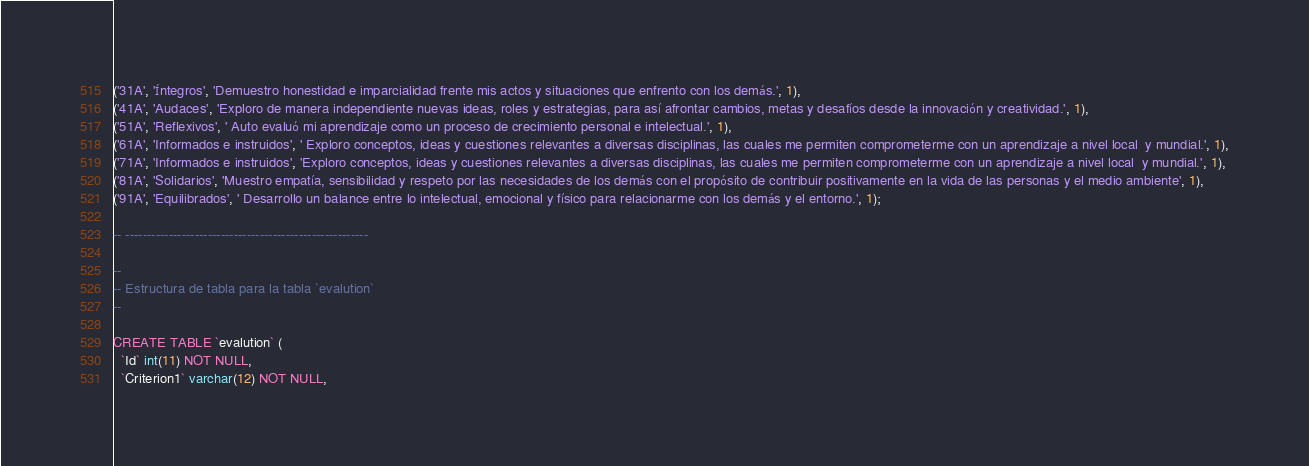<code> <loc_0><loc_0><loc_500><loc_500><_SQL_>('31A', 'Íntegros', 'Demuestro honestidad e imparcialidad frente mis actos y situaciones que enfrento con los demás.', 1),
('41A', 'Audaces', 'Exploro de manera independiente nuevas ideas, roles y estrategias, para así afrontar cambios, metas y desafíos desde la innovación y creatividad.', 1),
('51A', 'Reflexivos', ' Auto evaluó mi aprendizaje como un proceso de crecimiento personal e intelectual.', 1),
('61A', 'Informados e instruidos', ' Exploro conceptos, ideas y cuestiones relevantes a diversas disciplinas, las cuales me permiten comprometerme con un aprendizaje a nivel local  y mundial.', 1),
('71A', 'Informados e instruidos', 'Exploro conceptos, ideas y cuestiones relevantes a diversas disciplinas, las cuales me permiten comprometerme con un aprendizaje a nivel local  y mundial.', 1),
('81A', 'Solidarios', 'Muestro empatía, sensibilidad y respeto por las necesidades de los demás con el propósito de contribuir positivamente en la vida de las personas y el medio ambiente', 1),
('91A', 'Equilibrados', ' Desarrollo un balance entre lo intelectual, emocional y físico para relacionarme con los demás y el entorno.', 1);

-- --------------------------------------------------------

--
-- Estructura de tabla para la tabla `evalution`
--

CREATE TABLE `evalution` (
  `Id` int(11) NOT NULL,
  `Criterion1` varchar(12) NOT NULL,</code> 